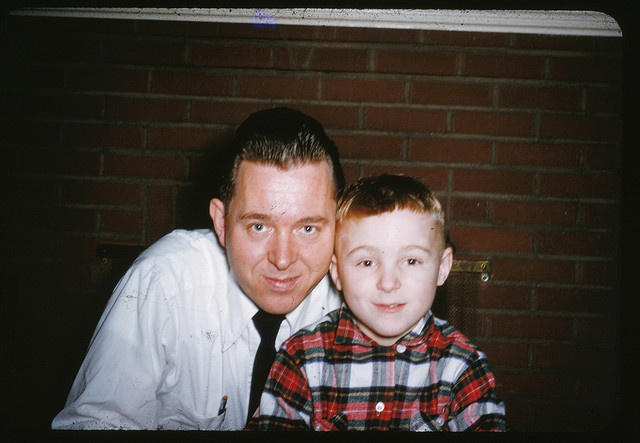Describe the objects in this image and their specific colors. I can see people in black, lightgray, darkgray, and lightpink tones, people in black, lightgray, maroon, and pink tones, and tie in black, gray, and purple tones in this image. 